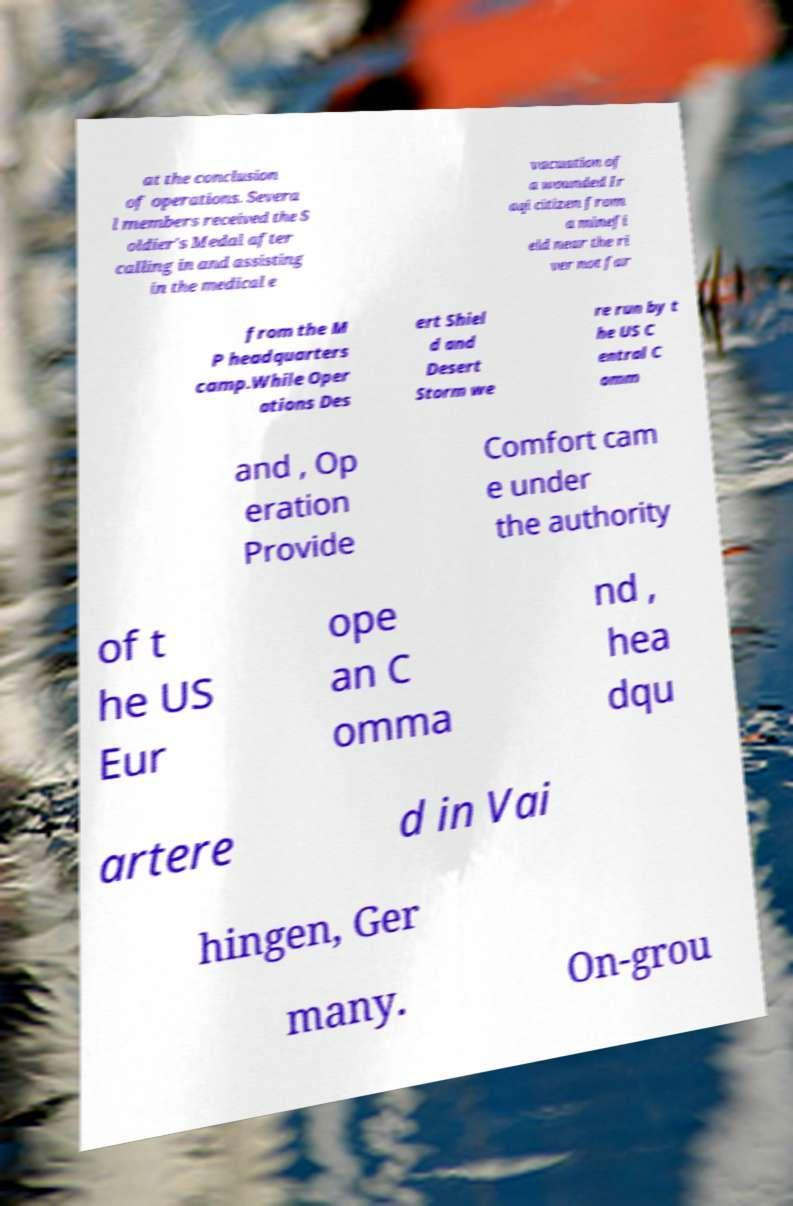Please identify and transcribe the text found in this image. at the conclusion of operations. Severa l members received the S oldier's Medal after calling in and assisting in the medical e vacuation of a wounded Ir aqi citizen from a minefi eld near the ri ver not far from the M P headquarters camp.While Oper ations Des ert Shiel d and Desert Storm we re run by t he US C entral C omm and , Op eration Provide Comfort cam e under the authority of t he US Eur ope an C omma nd , hea dqu artere d in Vai hingen, Ger many. On-grou 